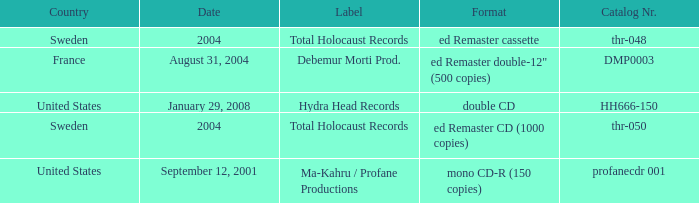What country is the Debemur Morti prod. label from? France. 